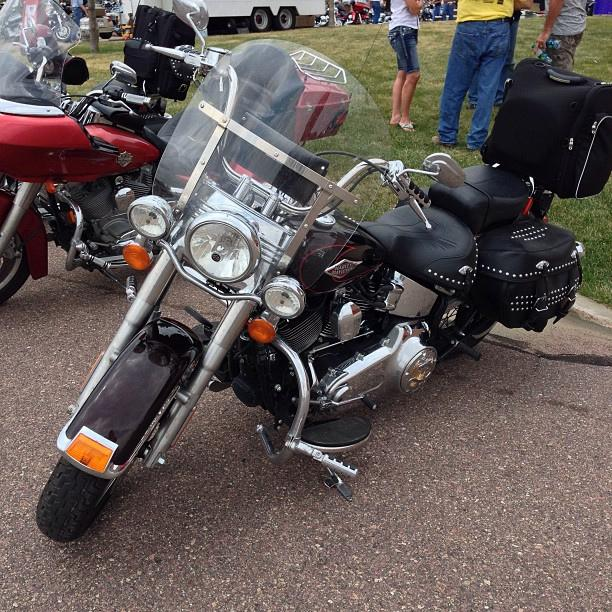Why is the man holding plastic bottles? Please explain your reasoning. to drink. The man has a beverage in the bottles. 